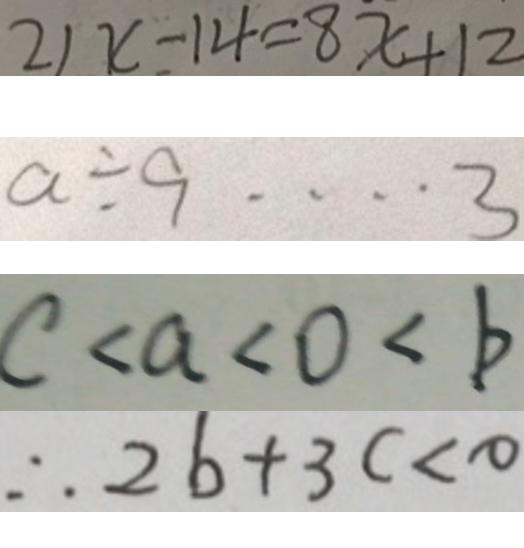<formula> <loc_0><loc_0><loc_500><loc_500>2 1 x - 1 4 = 8 x + 1 2 
 a \div 9 \cdots 3 
 c < a < 0 < b 
 \therefore 2 b + 3 c < 0</formula> 